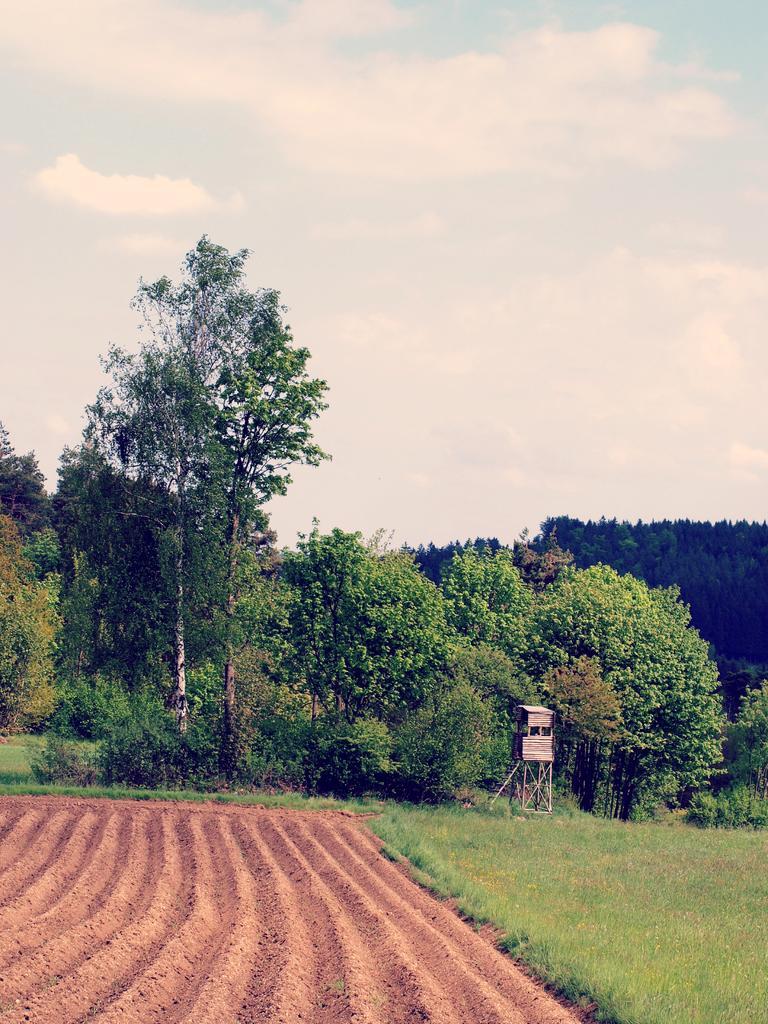Please provide a concise description of this image. As we can see there is a clear sky and there are lot of trees all around and in between there is a wooden house and on the ground there is a grass and beside it there is soil which is preparing for the farming. 